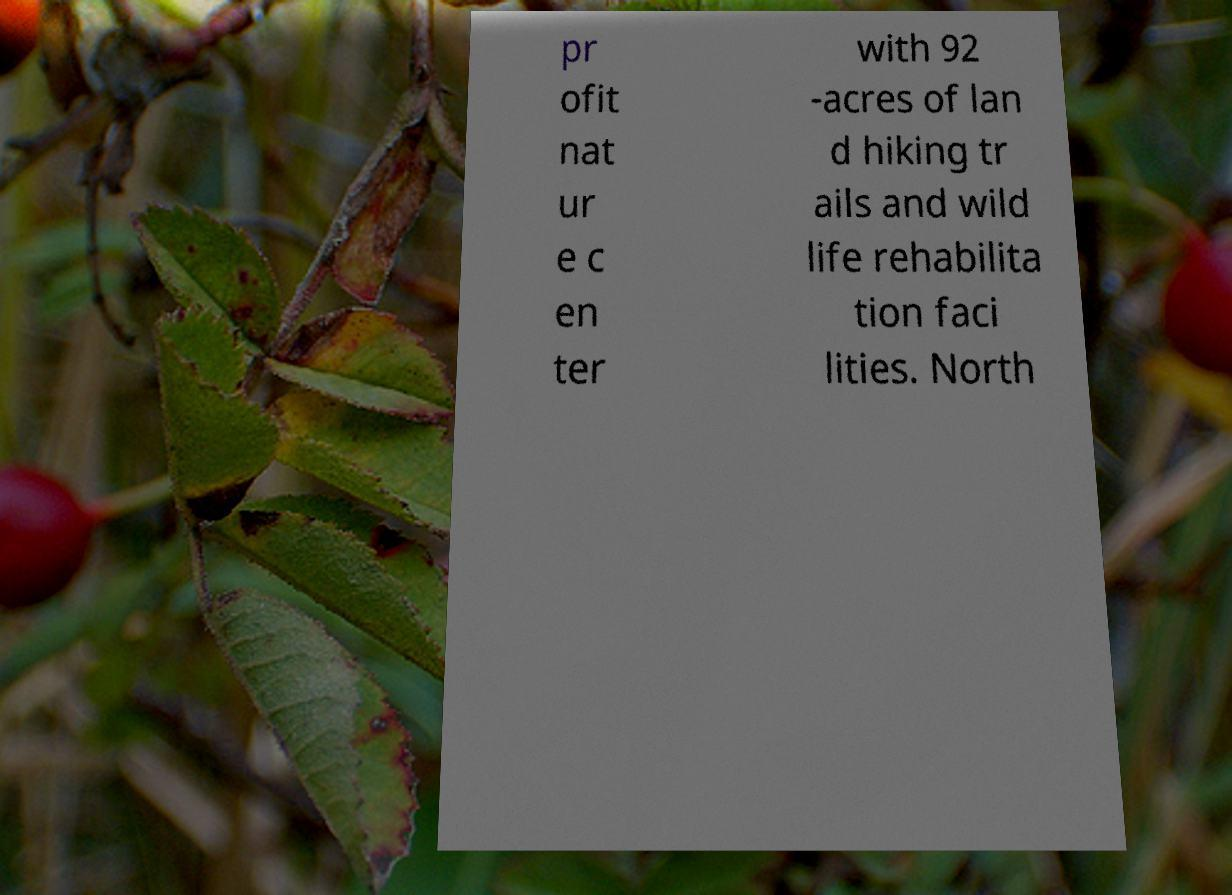Please identify and transcribe the text found in this image. pr ofit nat ur e c en ter with 92 -acres of lan d hiking tr ails and wild life rehabilita tion faci lities. North 